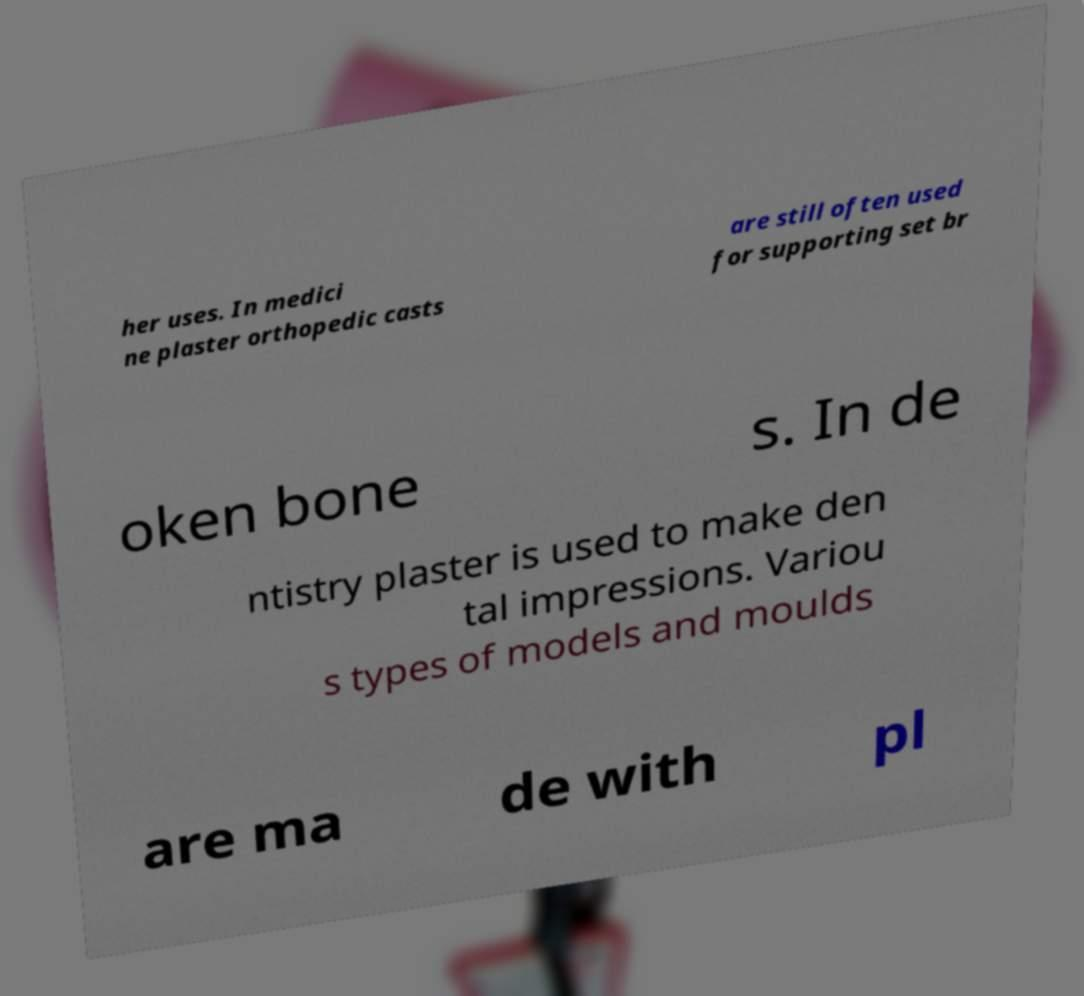Please identify and transcribe the text found in this image. her uses. In medici ne plaster orthopedic casts are still often used for supporting set br oken bone s. In de ntistry plaster is used to make den tal impressions. Variou s types of models and moulds are ma de with pl 